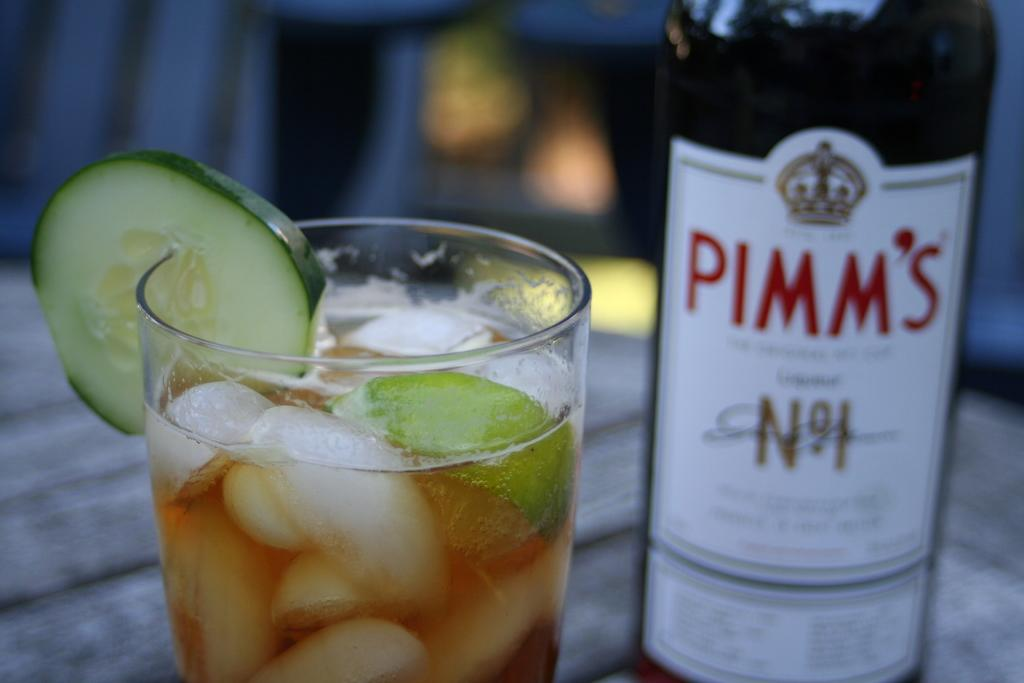<image>
Describe the image concisely. A bottle of Pimm's is next to a drink with ice and a lime in it. 